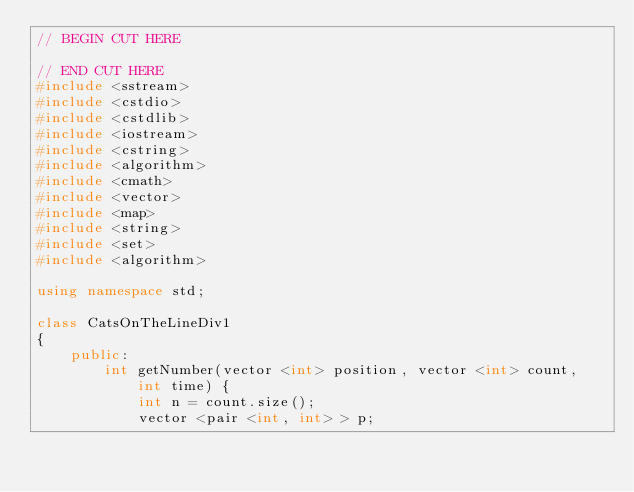Convert code to text. <code><loc_0><loc_0><loc_500><loc_500><_C++_>// BEGIN CUT HERE

// END CUT HERE
#include <sstream>
#include <cstdio>
#include <cstdlib>
#include <iostream>
#include <cstring>
#include <algorithm>
#include <cmath>
#include <vector>
#include <map>
#include <string>
#include <set>
#include <algorithm>

using namespace std;

class CatsOnTheLineDiv1
{
    public:
        int getNumber(vector <int> position, vector <int> count, int time) {
            int n = count.size();
            vector <pair <int, int> > p;</code> 